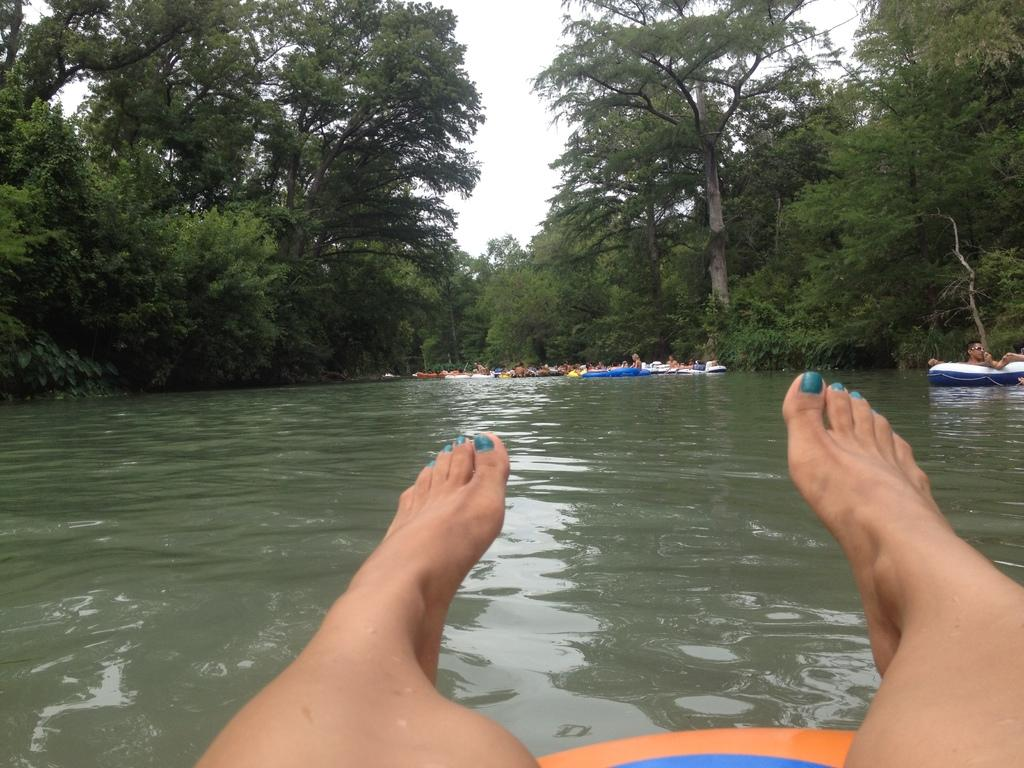What body part can be seen in the image? There are person's legs visible in the image. What is the main feature of the image? There is water in the image. What can be seen in the distance? People and boats are present in the distance. What type of vegetation is visible in the background? There are trees in the background of the image. What is visible in the sky? The sky is visible in the background of the image. What type of plastic item is being used by the person's aunt in the image? There is no information about a plastic item or the person's aunt in the image. 